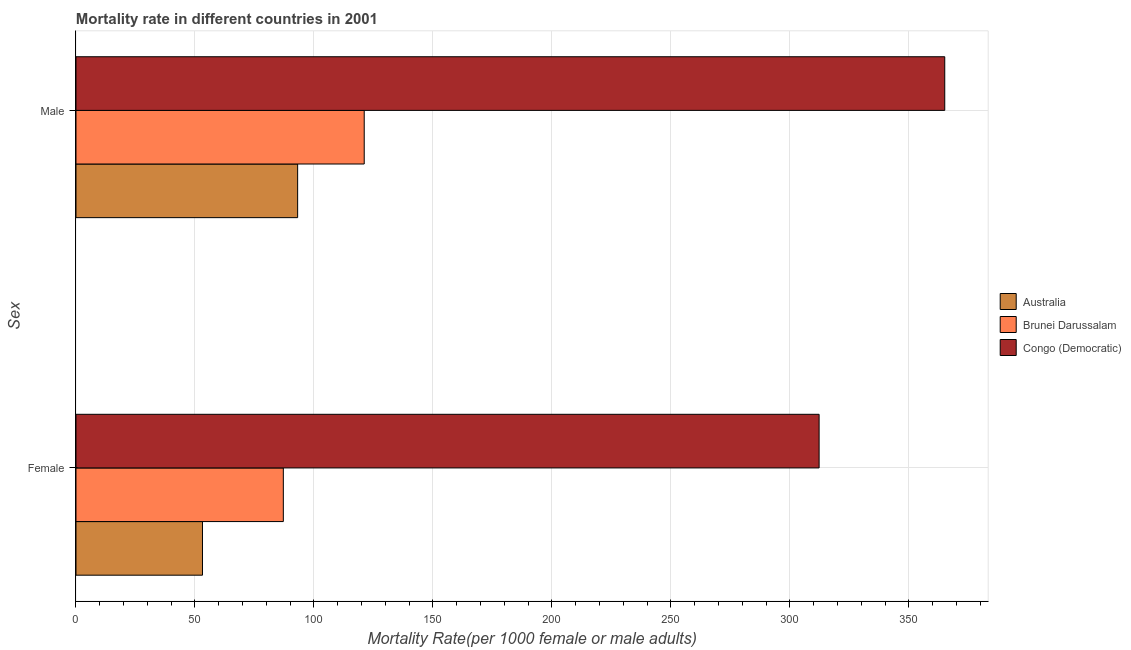How many different coloured bars are there?
Offer a very short reply. 3. How many groups of bars are there?
Provide a succinct answer. 2. Are the number of bars per tick equal to the number of legend labels?
Offer a very short reply. Yes. Are the number of bars on each tick of the Y-axis equal?
Your response must be concise. Yes. What is the label of the 2nd group of bars from the top?
Give a very brief answer. Female. What is the male mortality rate in Congo (Democratic)?
Keep it short and to the point. 365.04. Across all countries, what is the maximum male mortality rate?
Your response must be concise. 365.04. Across all countries, what is the minimum male mortality rate?
Offer a terse response. 93.13. In which country was the male mortality rate maximum?
Your answer should be very brief. Congo (Democratic). What is the total male mortality rate in the graph?
Keep it short and to the point. 579.29. What is the difference between the female mortality rate in Congo (Democratic) and that in Brunei Darussalam?
Make the answer very short. 225.13. What is the difference between the female mortality rate in Australia and the male mortality rate in Brunei Darussalam?
Your response must be concise. -67.96. What is the average female mortality rate per country?
Your answer should be very brief. 150.84. What is the difference between the female mortality rate and male mortality rate in Congo (Democratic)?
Offer a very short reply. -52.8. In how many countries, is the female mortality rate greater than 310 ?
Make the answer very short. 1. What is the ratio of the female mortality rate in Congo (Democratic) to that in Brunei Darussalam?
Offer a very short reply. 3.58. Is the female mortality rate in Brunei Darussalam less than that in Australia?
Ensure brevity in your answer.  No. What does the 2nd bar from the top in Female represents?
Your response must be concise. Brunei Darussalam. What does the 2nd bar from the bottom in Male represents?
Make the answer very short. Brunei Darussalam. How many bars are there?
Provide a short and direct response. 6. How many countries are there in the graph?
Ensure brevity in your answer.  3. Are the values on the major ticks of X-axis written in scientific E-notation?
Your answer should be compact. No. What is the title of the graph?
Keep it short and to the point. Mortality rate in different countries in 2001. Does "Luxembourg" appear as one of the legend labels in the graph?
Your answer should be very brief. No. What is the label or title of the X-axis?
Give a very brief answer. Mortality Rate(per 1000 female or male adults). What is the label or title of the Y-axis?
Your response must be concise. Sex. What is the Mortality Rate(per 1000 female or male adults) of Australia in Female?
Provide a short and direct response. 53.15. What is the Mortality Rate(per 1000 female or male adults) in Brunei Darussalam in Female?
Your answer should be compact. 87.12. What is the Mortality Rate(per 1000 female or male adults) of Congo (Democratic) in Female?
Your answer should be very brief. 312.25. What is the Mortality Rate(per 1000 female or male adults) of Australia in Male?
Your answer should be compact. 93.13. What is the Mortality Rate(per 1000 female or male adults) in Brunei Darussalam in Male?
Offer a terse response. 121.11. What is the Mortality Rate(per 1000 female or male adults) in Congo (Democratic) in Male?
Your answer should be compact. 365.04. Across all Sex, what is the maximum Mortality Rate(per 1000 female or male adults) in Australia?
Your answer should be compact. 93.13. Across all Sex, what is the maximum Mortality Rate(per 1000 female or male adults) in Brunei Darussalam?
Make the answer very short. 121.11. Across all Sex, what is the maximum Mortality Rate(per 1000 female or male adults) of Congo (Democratic)?
Give a very brief answer. 365.04. Across all Sex, what is the minimum Mortality Rate(per 1000 female or male adults) in Australia?
Your response must be concise. 53.15. Across all Sex, what is the minimum Mortality Rate(per 1000 female or male adults) of Brunei Darussalam?
Offer a terse response. 87.12. Across all Sex, what is the minimum Mortality Rate(per 1000 female or male adults) of Congo (Democratic)?
Ensure brevity in your answer.  312.25. What is the total Mortality Rate(per 1000 female or male adults) of Australia in the graph?
Your answer should be compact. 146.28. What is the total Mortality Rate(per 1000 female or male adults) of Brunei Darussalam in the graph?
Offer a terse response. 208.23. What is the total Mortality Rate(per 1000 female or male adults) in Congo (Democratic) in the graph?
Make the answer very short. 677.28. What is the difference between the Mortality Rate(per 1000 female or male adults) of Australia in Female and that in Male?
Offer a terse response. -39.98. What is the difference between the Mortality Rate(per 1000 female or male adults) of Brunei Darussalam in Female and that in Male?
Offer a very short reply. -33.99. What is the difference between the Mortality Rate(per 1000 female or male adults) in Congo (Democratic) in Female and that in Male?
Offer a very short reply. -52.8. What is the difference between the Mortality Rate(per 1000 female or male adults) in Australia in Female and the Mortality Rate(per 1000 female or male adults) in Brunei Darussalam in Male?
Give a very brief answer. -67.96. What is the difference between the Mortality Rate(per 1000 female or male adults) in Australia in Female and the Mortality Rate(per 1000 female or male adults) in Congo (Democratic) in Male?
Offer a terse response. -311.89. What is the difference between the Mortality Rate(per 1000 female or male adults) of Brunei Darussalam in Female and the Mortality Rate(per 1000 female or male adults) of Congo (Democratic) in Male?
Your response must be concise. -277.92. What is the average Mortality Rate(per 1000 female or male adults) of Australia per Sex?
Make the answer very short. 73.14. What is the average Mortality Rate(per 1000 female or male adults) in Brunei Darussalam per Sex?
Your answer should be very brief. 104.11. What is the average Mortality Rate(per 1000 female or male adults) of Congo (Democratic) per Sex?
Ensure brevity in your answer.  338.64. What is the difference between the Mortality Rate(per 1000 female or male adults) of Australia and Mortality Rate(per 1000 female or male adults) of Brunei Darussalam in Female?
Your response must be concise. -33.97. What is the difference between the Mortality Rate(per 1000 female or male adults) of Australia and Mortality Rate(per 1000 female or male adults) of Congo (Democratic) in Female?
Keep it short and to the point. -259.09. What is the difference between the Mortality Rate(per 1000 female or male adults) of Brunei Darussalam and Mortality Rate(per 1000 female or male adults) of Congo (Democratic) in Female?
Provide a succinct answer. -225.13. What is the difference between the Mortality Rate(per 1000 female or male adults) of Australia and Mortality Rate(per 1000 female or male adults) of Brunei Darussalam in Male?
Your response must be concise. -27.98. What is the difference between the Mortality Rate(per 1000 female or male adults) in Australia and Mortality Rate(per 1000 female or male adults) in Congo (Democratic) in Male?
Make the answer very short. -271.91. What is the difference between the Mortality Rate(per 1000 female or male adults) of Brunei Darussalam and Mortality Rate(per 1000 female or male adults) of Congo (Democratic) in Male?
Provide a succinct answer. -243.93. What is the ratio of the Mortality Rate(per 1000 female or male adults) in Australia in Female to that in Male?
Ensure brevity in your answer.  0.57. What is the ratio of the Mortality Rate(per 1000 female or male adults) in Brunei Darussalam in Female to that in Male?
Give a very brief answer. 0.72. What is the ratio of the Mortality Rate(per 1000 female or male adults) in Congo (Democratic) in Female to that in Male?
Ensure brevity in your answer.  0.86. What is the difference between the highest and the second highest Mortality Rate(per 1000 female or male adults) of Australia?
Make the answer very short. 39.98. What is the difference between the highest and the second highest Mortality Rate(per 1000 female or male adults) of Brunei Darussalam?
Offer a very short reply. 33.99. What is the difference between the highest and the second highest Mortality Rate(per 1000 female or male adults) in Congo (Democratic)?
Offer a terse response. 52.8. What is the difference between the highest and the lowest Mortality Rate(per 1000 female or male adults) in Australia?
Your response must be concise. 39.98. What is the difference between the highest and the lowest Mortality Rate(per 1000 female or male adults) in Brunei Darussalam?
Offer a terse response. 33.99. What is the difference between the highest and the lowest Mortality Rate(per 1000 female or male adults) in Congo (Democratic)?
Your response must be concise. 52.8. 